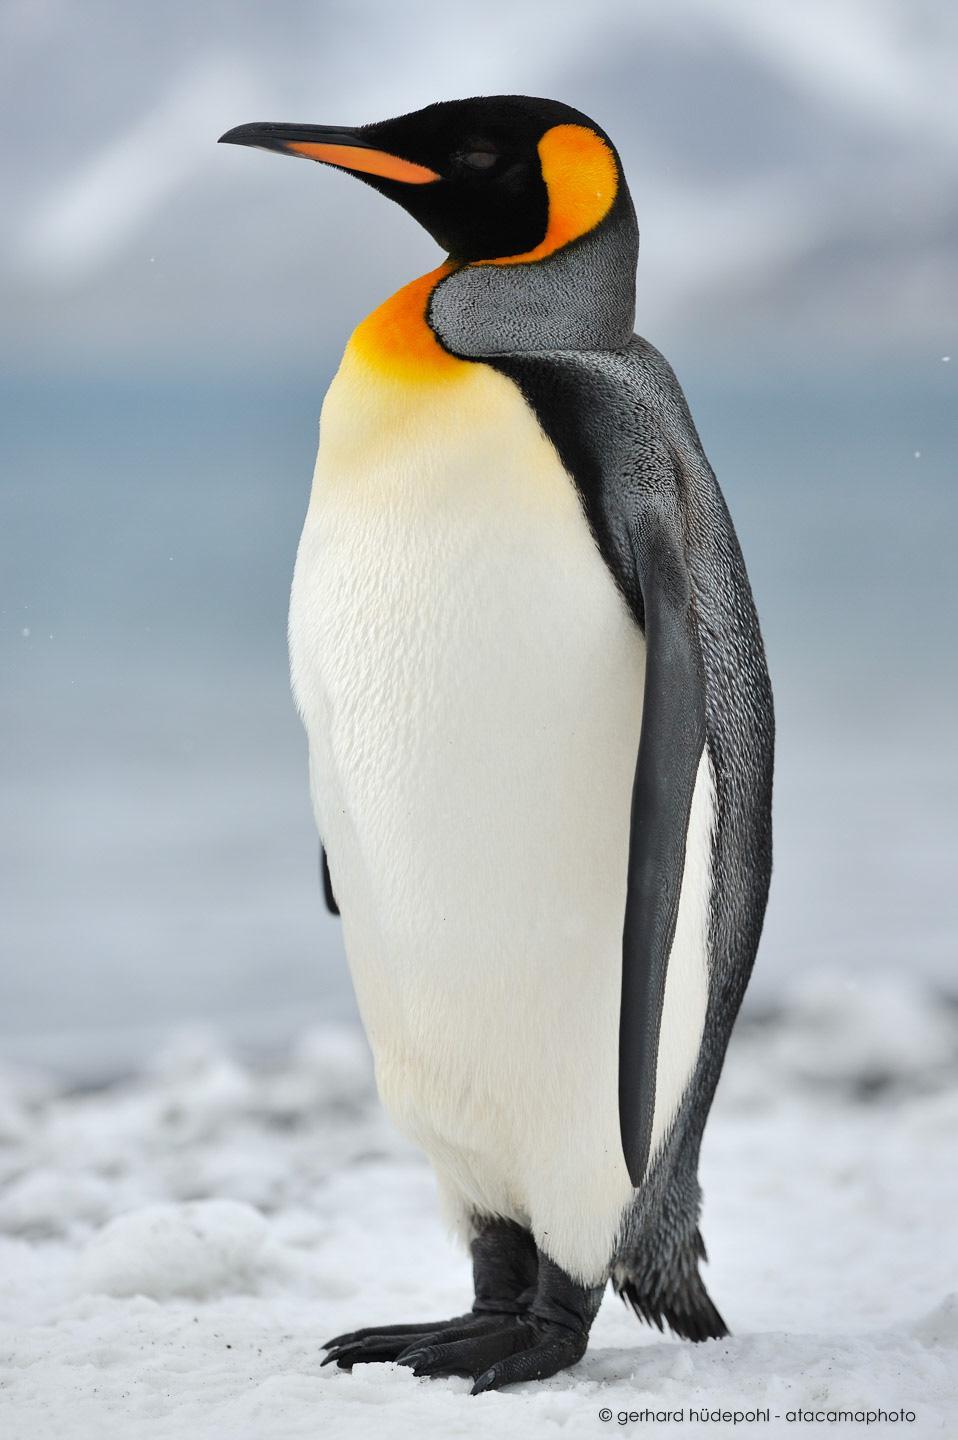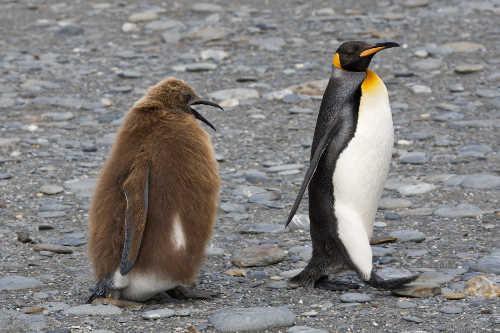The first image is the image on the left, the second image is the image on the right. Evaluate the accuracy of this statement regarding the images: "There are no more than five penguins". Is it true? Answer yes or no. Yes. The first image is the image on the left, the second image is the image on the right. Considering the images on both sides, is "There are three or fewer penguins in total." valid? Answer yes or no. Yes. The first image is the image on the left, the second image is the image on the right. Given the left and right images, does the statement "One of the images shows a single penguin standing on two legs and facing the left." hold true? Answer yes or no. Yes. 